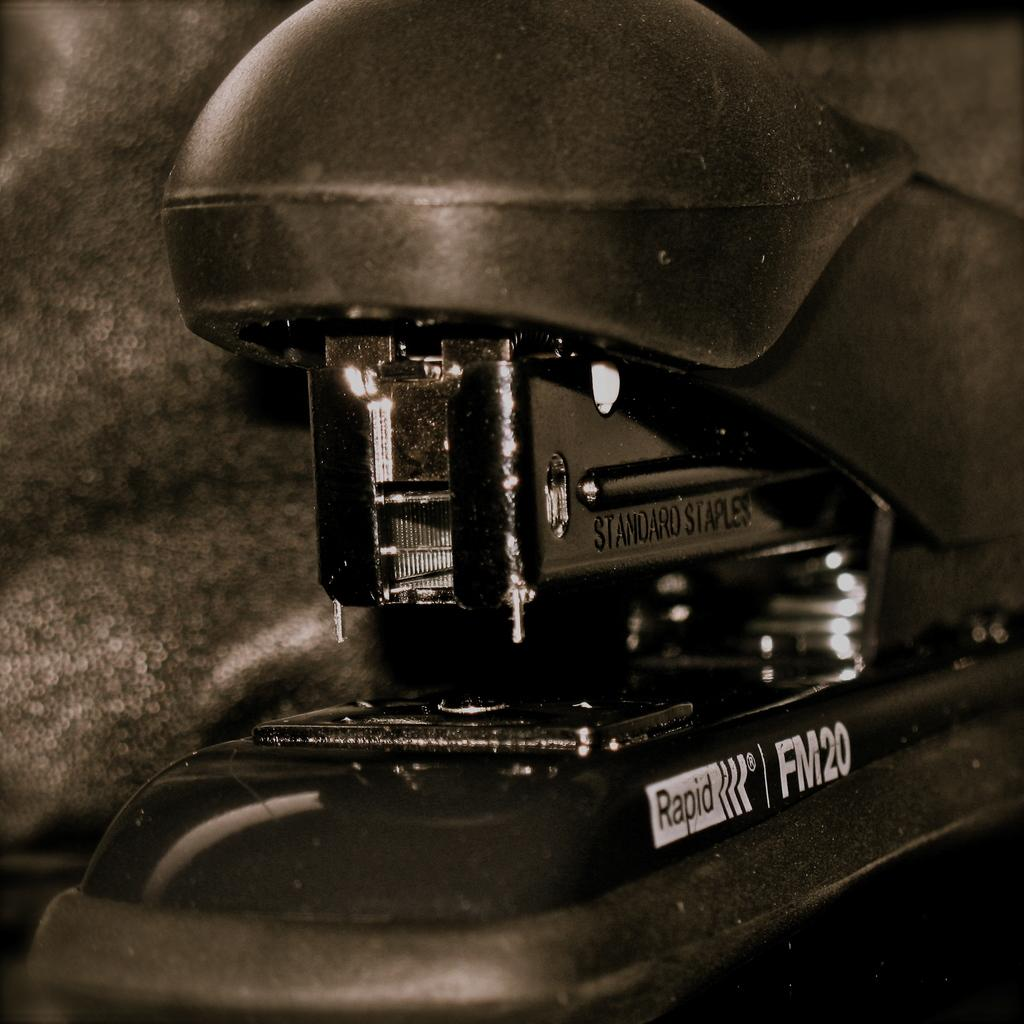What is the color scheme of the image? The image is black and white. What object can be seen in the image? There is a stapler in the image. Is there any text or labeling on the stapler or something related to it? Yes, there is writing on the stapler or something related to it. What type of suit is the person wearing in the image? There is no person or suit present in the image; it only features a stapler with writing on it. How much popcorn is visible in the image? There is no popcorn present in the image. 